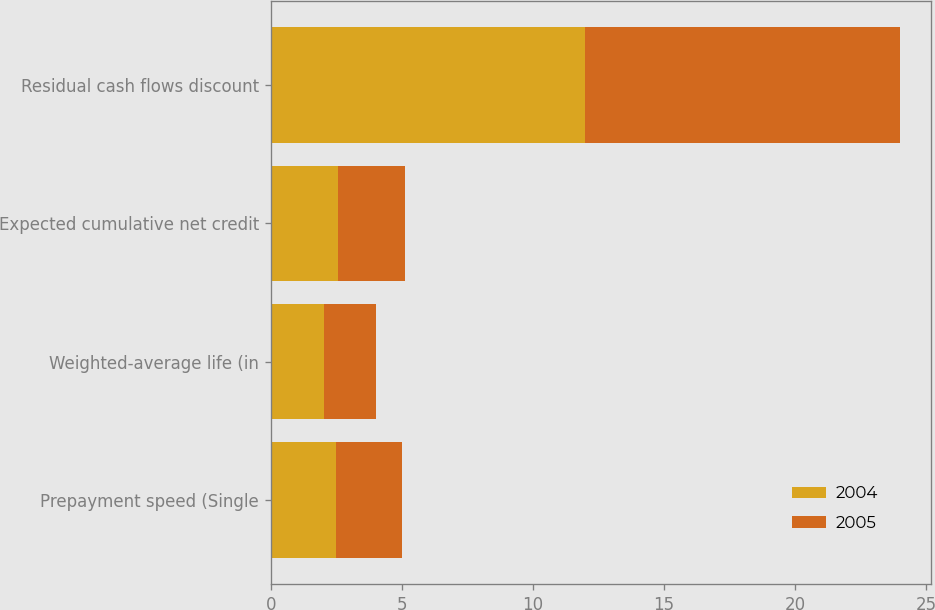<chart> <loc_0><loc_0><loc_500><loc_500><stacked_bar_chart><ecel><fcel>Prepayment speed (Single<fcel>Weighted-average life (in<fcel>Expected cumulative net credit<fcel>Residual cash flows discount<nl><fcel>2004<fcel>2.5<fcel>2.02<fcel>2.57<fcel>12<nl><fcel>2005<fcel>2.5<fcel>2<fcel>2.55<fcel>12<nl></chart> 